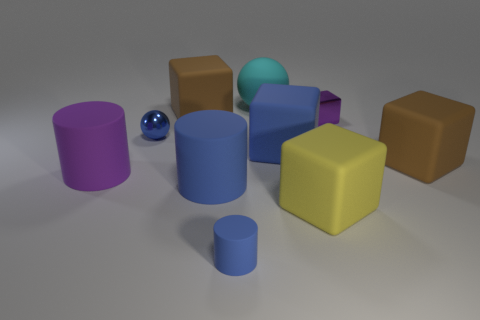Subtract 1 blocks. How many blocks are left? 4 Subtract all balls. How many objects are left? 8 Subtract all blue rubber cubes. Subtract all big brown rubber blocks. How many objects are left? 7 Add 3 blue matte cylinders. How many blue matte cylinders are left? 5 Add 7 purple shiny things. How many purple shiny things exist? 8 Subtract 0 red cylinders. How many objects are left? 10 